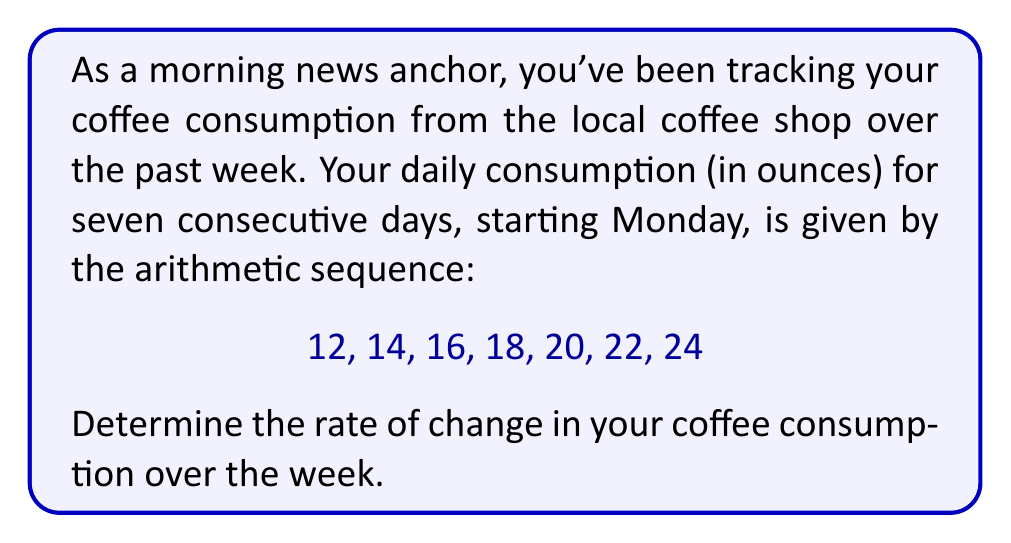Provide a solution to this math problem. To solve this problem, we need to understand that the rate of change in an arithmetic sequence is constant and is equal to the common difference between consecutive terms. Let's approach this step-by-step:

1) First, let's identify the arithmetic sequence:
   $a_1 = 12, a_2 = 14, a_3 = 16, a_4 = 18, a_5 = 20, a_6 = 22, a_7 = 24$

2) In an arithmetic sequence, the common difference $d$ is given by:
   $d = a_{n+1} - a_n$, where $n$ is any term number.

3) Let's calculate $d$ using the first two terms:
   $d = a_2 - a_1 = 14 - 12 = 2$

4) We can verify this for other consecutive terms:
   $a_3 - a_2 = 16 - 14 = 2$
   $a_4 - a_3 = 18 - 16 = 2$
   And so on...

5) The rate of change is this common difference $d$. However, we need to express it in terms of ounces per day:

   Rate of change = $\frac{2 \text{ ounces}}{\text{1 day}}$ = 2 ounces/day

This means that each day, your coffee consumption increased by 2 ounces.

6) We can also express this as a weekly rate:
   Weekly rate of change = $2 \text{ ounces/day} \times 7 \text{ days} = 14 \text{ ounces/week}$

Therefore, the rate of change in your coffee consumption is 2 ounces per day, or 14 ounces per week.
Answer: The rate of change in coffee consumption is 2 ounces per day, or equivalently, 14 ounces per week. 